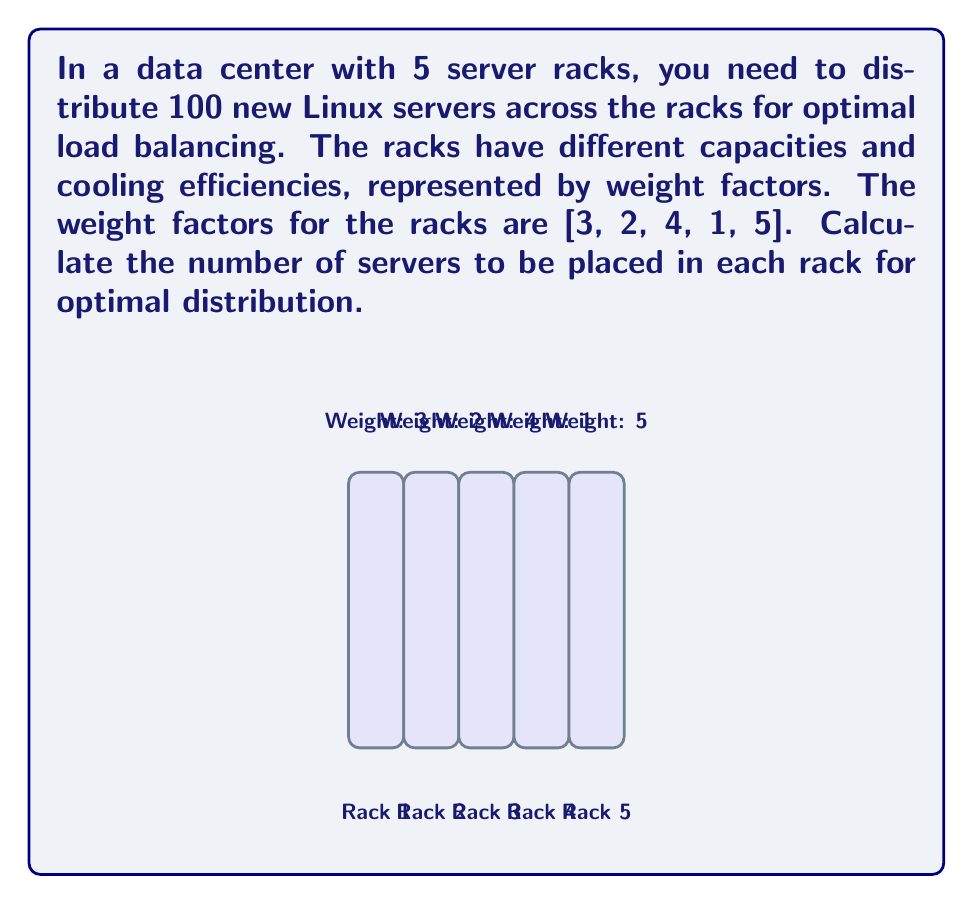Show me your answer to this math problem. To solve this problem, we'll use the weighted distribution method:

1) Calculate the sum of all weight factors:
   $$ \text{Total Weight} = 3 + 2 + 4 + 1 + 5 = 15 $$

2) Calculate the fraction of servers for each rack:
   $$ \text{Fraction}_i = \frac{\text{Weight}_i}{\text{Total Weight}} $$

3) Multiply the fraction by the total number of servers (100) for each rack:

   Rack 1: $$ \frac{3}{15} \times 100 = 20 \text{ servers} $$
   Rack 2: $$ \frac{2}{15} \times 100 = 13.33 \text{ servers} $$
   Rack 3: $$ \frac{4}{15} \times 100 = 26.67 \text{ servers} $$
   Rack 4: $$ \frac{1}{15} \times 100 = 6.67 \text{ servers} $$
   Rack 5: $$ \frac{5}{15} \times 100 = 33.33 \text{ servers} $$

4) Round to the nearest whole number:
   Rack 1: 20 servers
   Rack 2: 13 servers
   Rack 3: 27 servers
   Rack 4: 7 servers
   Rack 5: 33 servers

5) Verify the total:
   $$ 20 + 13 + 27 + 7 + 33 = 100 \text{ servers} $$

This distribution ensures optimal load balancing across the racks based on their weights.
Answer: [20, 13, 27, 7, 33] 